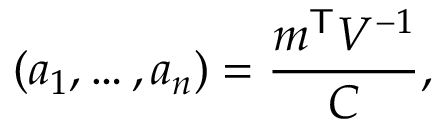<formula> <loc_0><loc_0><loc_500><loc_500>( a _ { 1 } , \dots , a _ { n } ) = { \frac { m ^ { T } V ^ { - 1 } } { C } } ,</formula> 